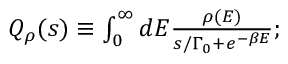Convert formula to latex. <formula><loc_0><loc_0><loc_500><loc_500>\begin{array} { r } { Q _ { \rho } ( s ) \equiv \int _ { 0 } ^ { \infty } d E \frac { \rho ( E ) } { s / \Gamma _ { 0 } + e ^ { - \beta E } } ; } \end{array}</formula> 